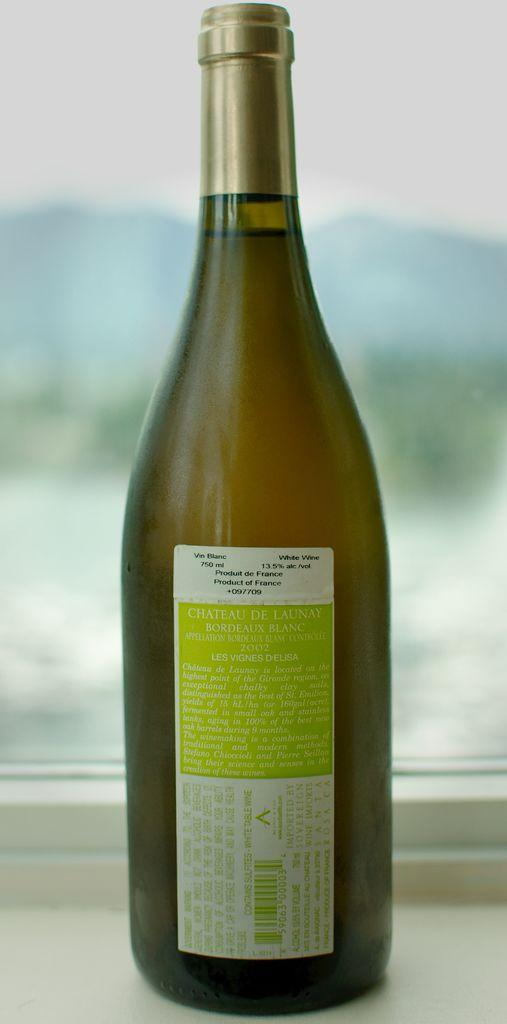Provide a one-sentence caption for the provided image. The label on a bottle of wine indicates that it is a product of France. 